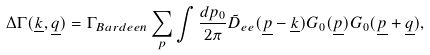Convert formula to latex. <formula><loc_0><loc_0><loc_500><loc_500>\Delta \Gamma ( \underline { k } , \underline { q } ) = \Gamma _ { B a r d e e n } \sum _ { p } \int \frac { d p _ { 0 } } { 2 \pi } \tilde { D } _ { e e } ( \underline { p } - \underline { k } ) G _ { 0 } ( \underline { p } ) G _ { 0 } ( \underline { p } + \underline { q } ) ,</formula> 